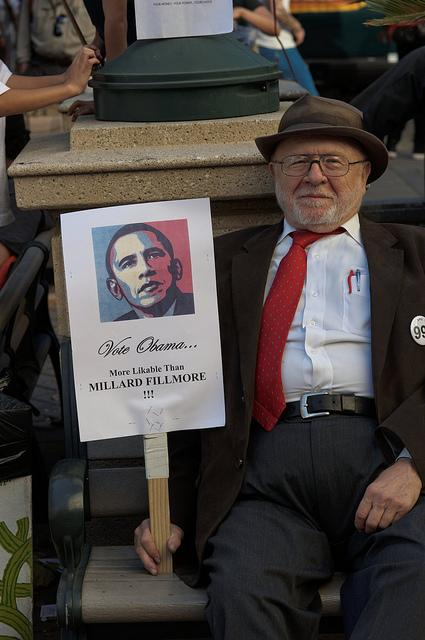Under what circumstance might children wear the red item the man is wearing?

Choices:
A) swimming
B) school
C) military
D) recreation school 